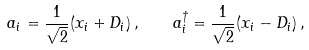Convert formula to latex. <formula><loc_0><loc_0><loc_500><loc_500>a _ { i } = \frac { 1 } { \sqrt { 2 } } ( x _ { i } + D _ { i } ) \, , \quad a ^ { \dagger } _ { i } = \frac { 1 } { \sqrt { 2 } } ( x _ { i } - D _ { i } ) \, ,</formula> 